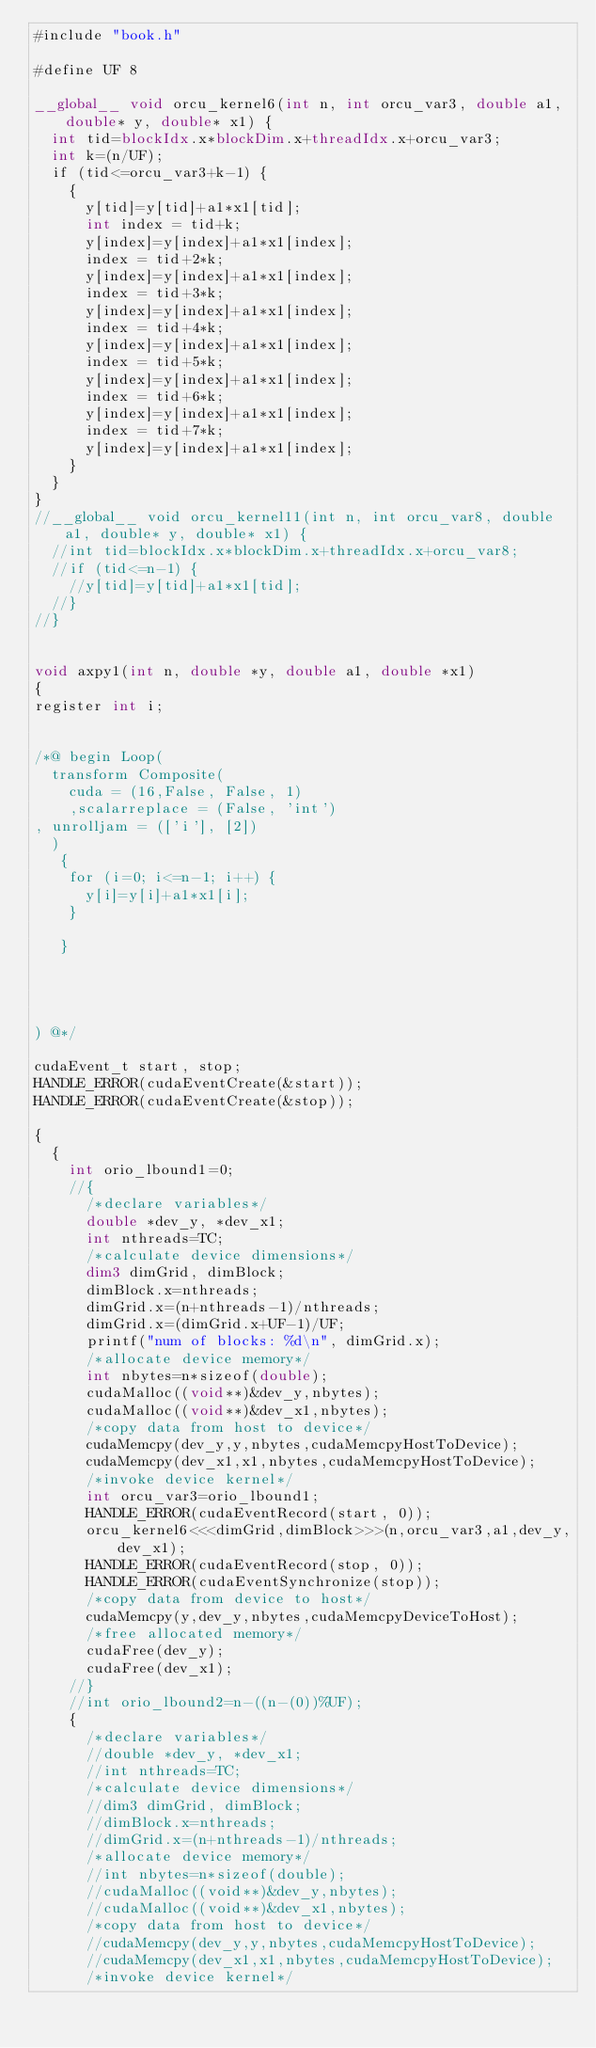<code> <loc_0><loc_0><loc_500><loc_500><_Cuda_>#include "book.h"

#define UF 8

__global__ void orcu_kernel6(int n, int orcu_var3, double a1, double* y, double* x1) {
  int tid=blockIdx.x*blockDim.x+threadIdx.x+orcu_var3;
  int k=(n/UF);
  if (tid<=orcu_var3+k-1) {
    {
      y[tid]=y[tid]+a1*x1[tid];
      int index = tid+k;
      y[index]=y[index]+a1*x1[index];
      index = tid+2*k;
      y[index]=y[index]+a1*x1[index];
      index = tid+3*k;
      y[index]=y[index]+a1*x1[index];
      index = tid+4*k;
      y[index]=y[index]+a1*x1[index];
      index = tid+5*k;
      y[index]=y[index]+a1*x1[index];
      index = tid+6*k;
      y[index]=y[index]+a1*x1[index];
      index = tid+7*k;
      y[index]=y[index]+a1*x1[index];
    }
  }
}
//__global__ void orcu_kernel11(int n, int orcu_var8, double a1, double* y, double* x1) {
  //int tid=blockIdx.x*blockDim.x+threadIdx.x+orcu_var8;
  //if (tid<=n-1) {
    //y[tid]=y[tid]+a1*x1[tid];
  //}
//}


void axpy1(int n, double *y, double a1, double *x1)
{
register int i;


/*@ begin Loop(
  transform Composite(
    cuda = (16,False, False, 1)
    ,scalarreplace = (False, 'int')
, unrolljam = (['i'], [2])
  )
   {
    for (i=0; i<=n-1; i++) {
    	y[i]=y[i]+a1*x1[i];
    }
    
   }


   
  
) @*/

cudaEvent_t start, stop;
HANDLE_ERROR(cudaEventCreate(&start));
HANDLE_ERROR(cudaEventCreate(&stop));

{
  {
    int orio_lbound1=0;
    //{
      /*declare variables*/
      double *dev_y, *dev_x1;
      int nthreads=TC;
      /*calculate device dimensions*/
      dim3 dimGrid, dimBlock;
      dimBlock.x=nthreads;
      dimGrid.x=(n+nthreads-1)/nthreads;
      dimGrid.x=(dimGrid.x+UF-1)/UF;
      printf("num of blocks: %d\n", dimGrid.x);
      /*allocate device memory*/
      int nbytes=n*sizeof(double);
      cudaMalloc((void**)&dev_y,nbytes);
      cudaMalloc((void**)&dev_x1,nbytes);
      /*copy data from host to device*/
      cudaMemcpy(dev_y,y,nbytes,cudaMemcpyHostToDevice);
      cudaMemcpy(dev_x1,x1,nbytes,cudaMemcpyHostToDevice);
      /*invoke device kernel*/
      int orcu_var3=orio_lbound1;
      HANDLE_ERROR(cudaEventRecord(start, 0));
      orcu_kernel6<<<dimGrid,dimBlock>>>(n,orcu_var3,a1,dev_y,dev_x1);
      HANDLE_ERROR(cudaEventRecord(stop, 0));
      HANDLE_ERROR(cudaEventSynchronize(stop));
      /*copy data from device to host*/
      cudaMemcpy(y,dev_y,nbytes,cudaMemcpyDeviceToHost);
      /*free allocated memory*/
      cudaFree(dev_y);
      cudaFree(dev_x1);
    //}
    //int orio_lbound2=n-((n-(0))%UF);
    {
      /*declare variables*/
      //double *dev_y, *dev_x1;
      //int nthreads=TC;
      /*calculate device dimensions*/
      //dim3 dimGrid, dimBlock;
      //dimBlock.x=nthreads;
      //dimGrid.x=(n+nthreads-1)/nthreads;
      /*allocate device memory*/
      //int nbytes=n*sizeof(double);
      //cudaMalloc((void**)&dev_y,nbytes);
      //cudaMalloc((void**)&dev_x1,nbytes);
      /*copy data from host to device*/
      //cudaMemcpy(dev_y,y,nbytes,cudaMemcpyHostToDevice);
      //cudaMemcpy(dev_x1,x1,nbytes,cudaMemcpyHostToDevice);
      /*invoke device kernel*/</code> 